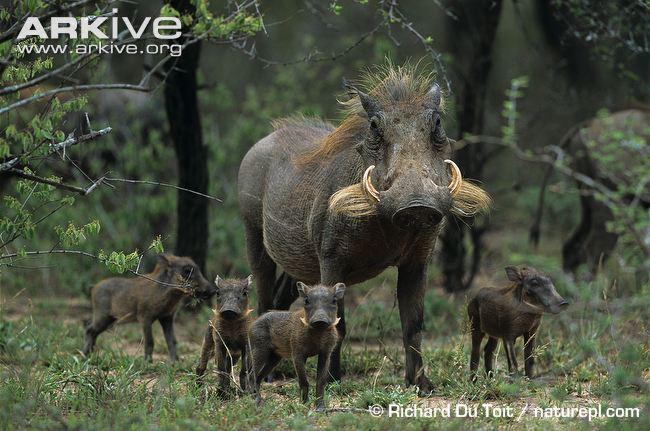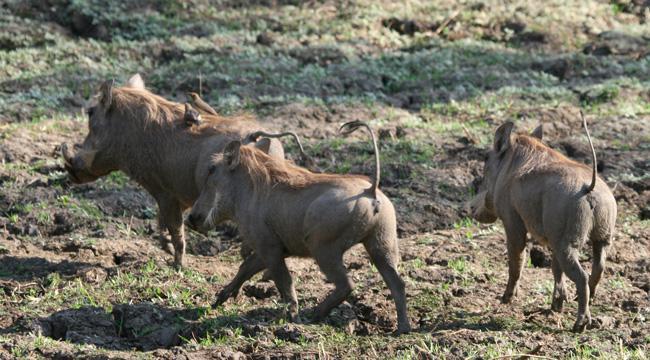The first image is the image on the left, the second image is the image on the right. Analyze the images presented: Is the assertion "An image includes a warthog that is standing with its front knees on the ground." valid? Answer yes or no. No. The first image is the image on the left, the second image is the image on the right. Given the left and right images, does the statement "There are no more than two boars with tusks." hold true? Answer yes or no. No. 